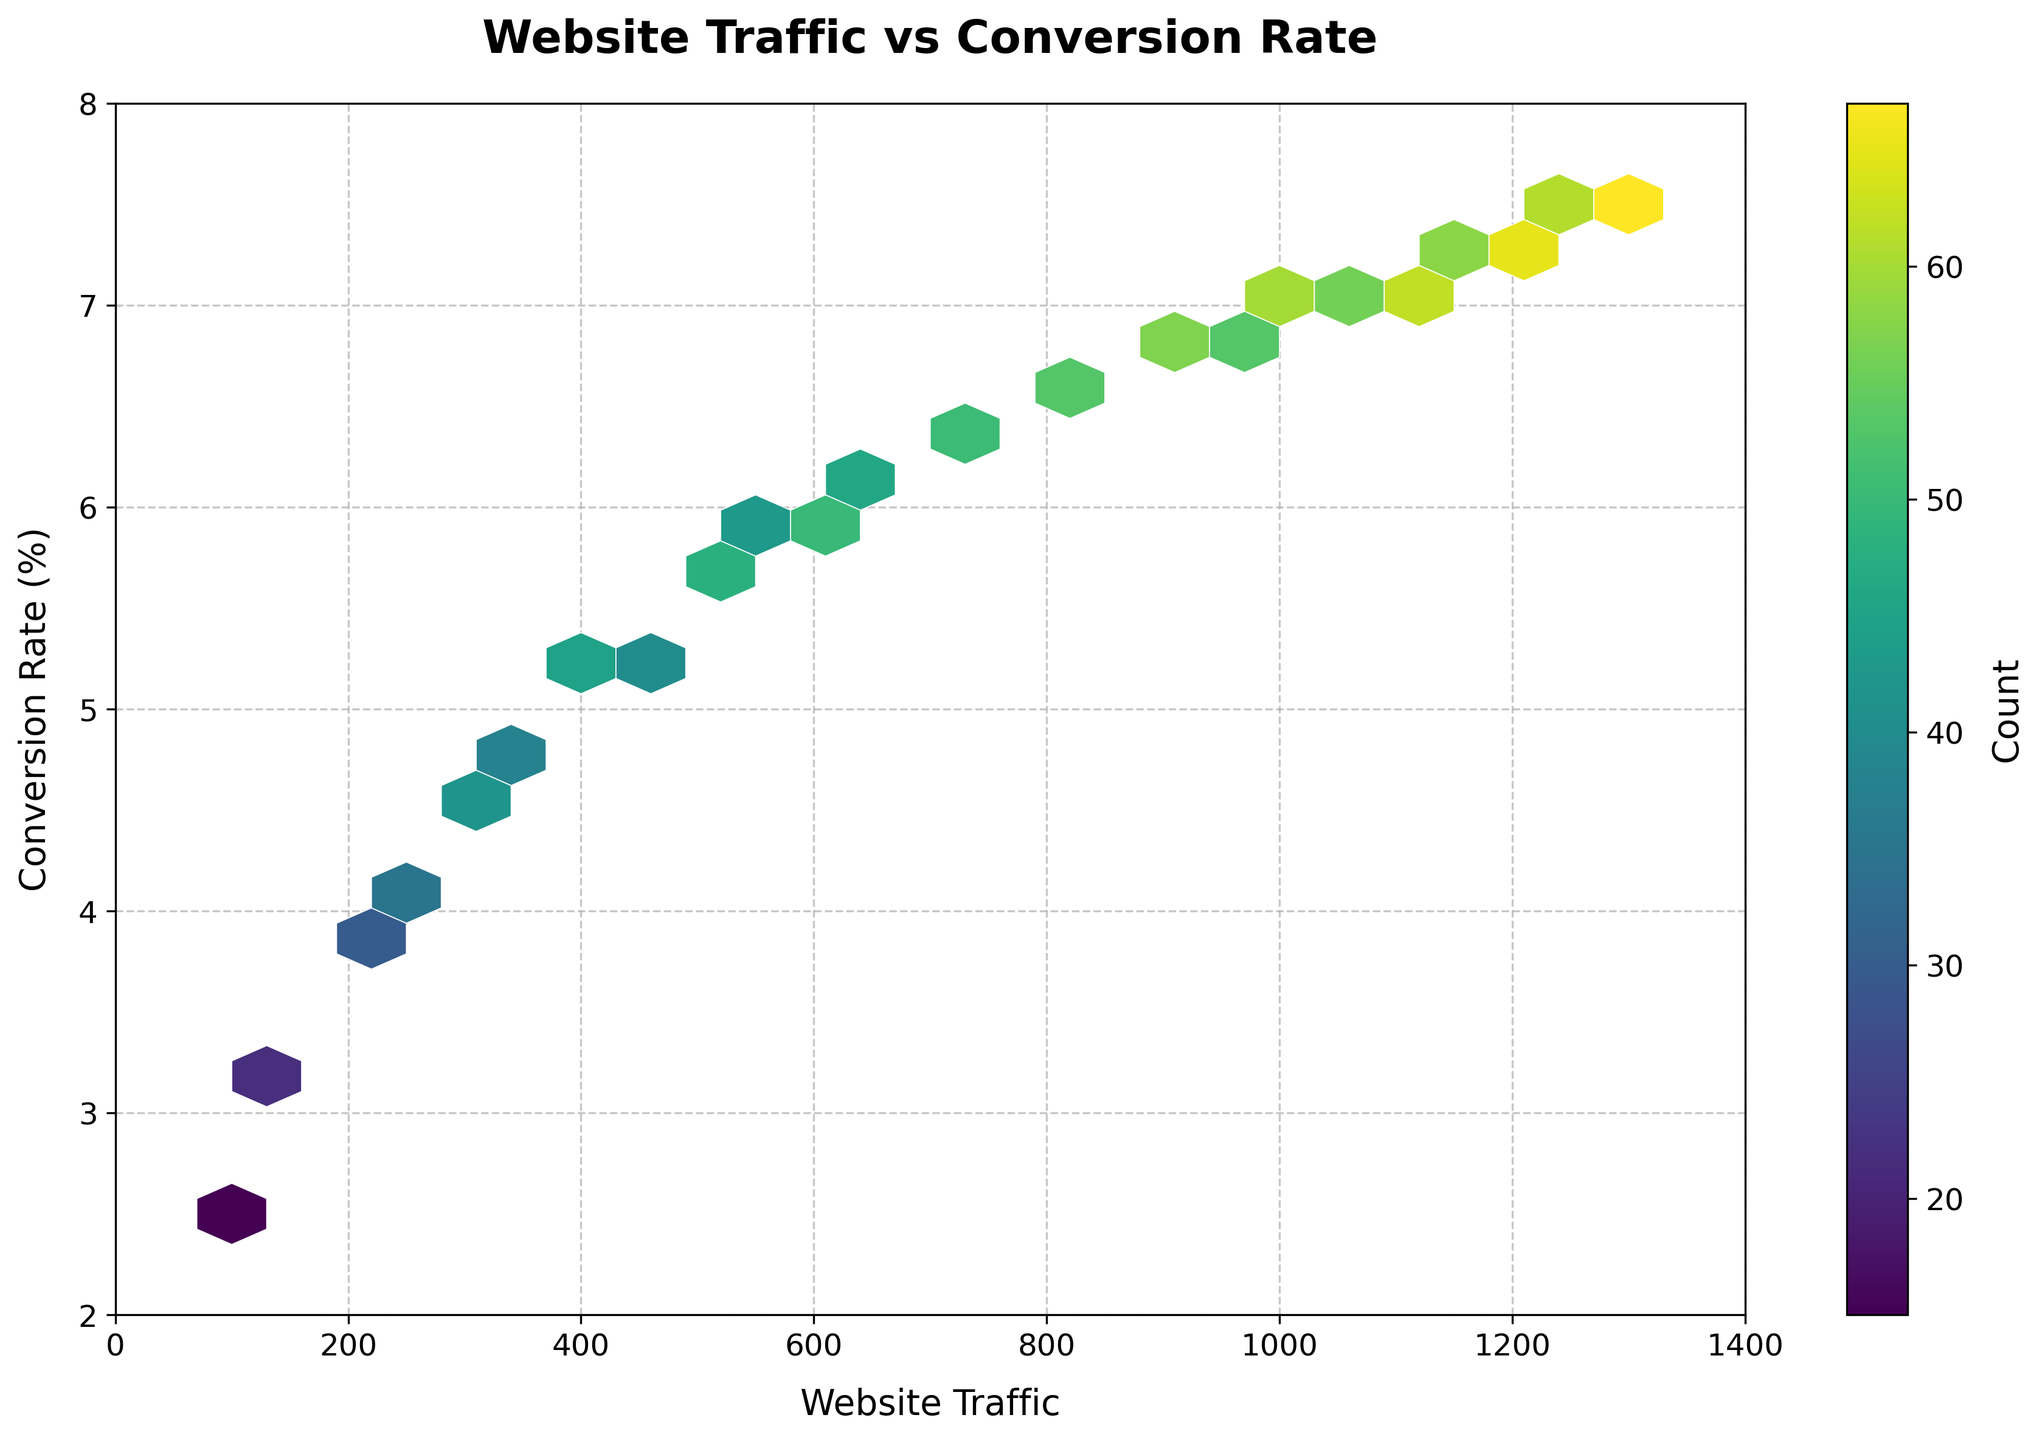What's the title of the figure? The title is displayed at the top of the figure in bold and large font. It reads "Website Traffic vs Conversion Rate".
Answer: Website Traffic vs Conversion Rate What are the labels of the X and Y axes? The X-axis label is located underneath the horizontal axis and reads "Website Traffic". The Y-axis label is beside the vertical axis and reads "Conversion Rate (%)".
Answer: Website Traffic, Conversion Rate (%) What color is used to indicate the highest counts in the hexbins? The color bar on the right side of the figure shows the color gradient from lowest to highest count. The highest count is represented by a bright yellow color.
Answer: Bright yellow What is the range of the X-axis? The X-axis starts from 0 on the left and goes up to 1400 on the right, as indicated by the numerical ticks along the axis.
Answer: 0 to 1400 What is the range of the Y-axis? The Y-axis starts from 2 at the bottom and goes up to 8 at the top, as indicated by the numerical ticks along the axis.
Answer: 2 to 8 What is the count at the hexbin where Website Traffic is 1000 and Conversion Rate is 6.9? Locate the hexbin corresponding to Website Traffic of 1000 on the X-axis and Conversion Rate of 6.9 on the Y-axis. The color bar shows that the hexbin is bright yellow, which corresponds to a count of 60.
Answer: 60 Which Website Traffic interval shows the highest conversion rates between 5.5% and 6.5%? Identify the hexagons along the range of Conversion Rates between 5.5% and 6.5%. The color intensifies around Website Traffic values from 500 to 900. The highest density of hexagons indicates the most frequent traffic counts in this interval.
Answer: 500 to 900 What is the conversion rate at its highest frequency count in the data? Identify the brightest hexbin on the plot, which corresponds to the highest count. This is at a Website Traffic around 900 and Conversion Rate of 6.7%. The color bar indicates this area corresponds to the highest count of 57.
Answer: 6.7% Are there more data points with a conversion rate below 5% or above 5%? To answer this, look at the density of hexagons below and above the 5% Conversion Rate. The hexagons above 5% are denser overall compared to those below 5%, indicating more data points have conversion rates above 5%.
Answer: Above 5% How does Website Traffic affect Conversion Rate based on the pattern in the hexbin plot? Observing the hexbin plot, as Website Traffic increases, the Conversion Rate generally increases, indicated by the upward sloping density of hexagons. The densest areas are from mid-to-high traffic counts and higher conversion rates, suggesting positive correlation.
Answer: Positive correlation 